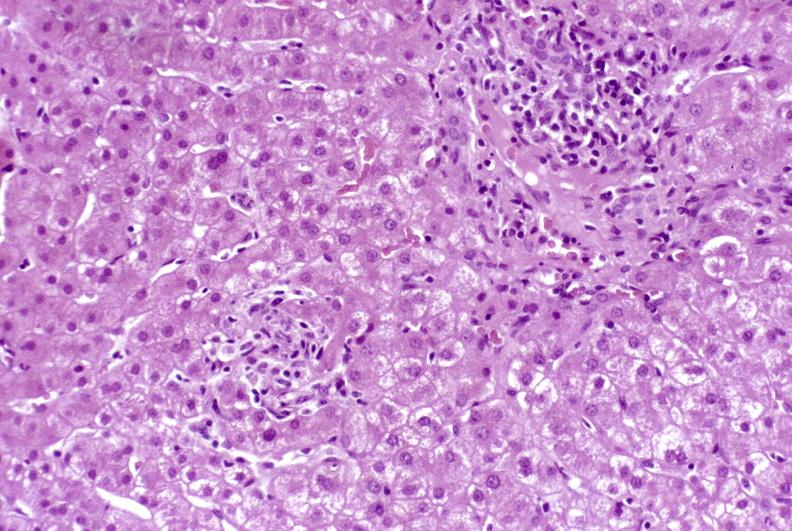what is present?
Answer the question using a single word or phrase. Hepatobiliary 